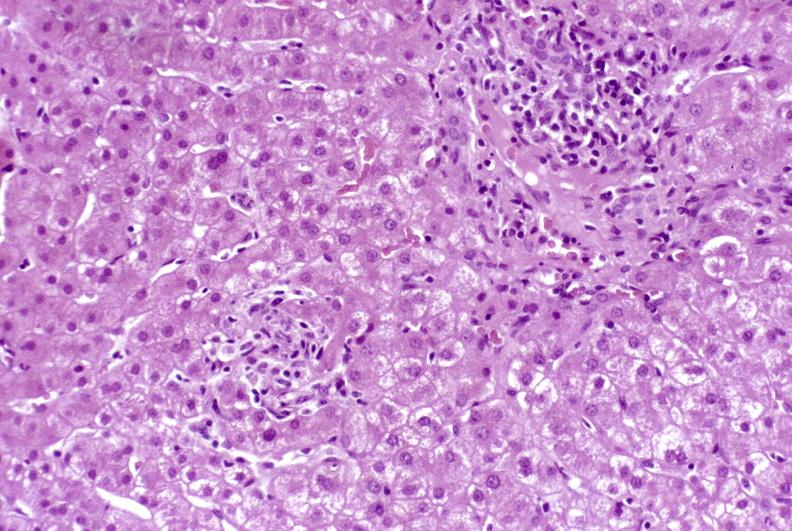what is present?
Answer the question using a single word or phrase. Hepatobiliary 